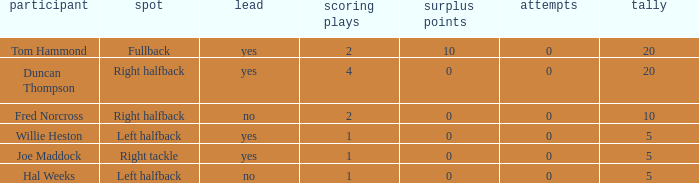What is the lowest number of field goals when the points were less than 5? None. 